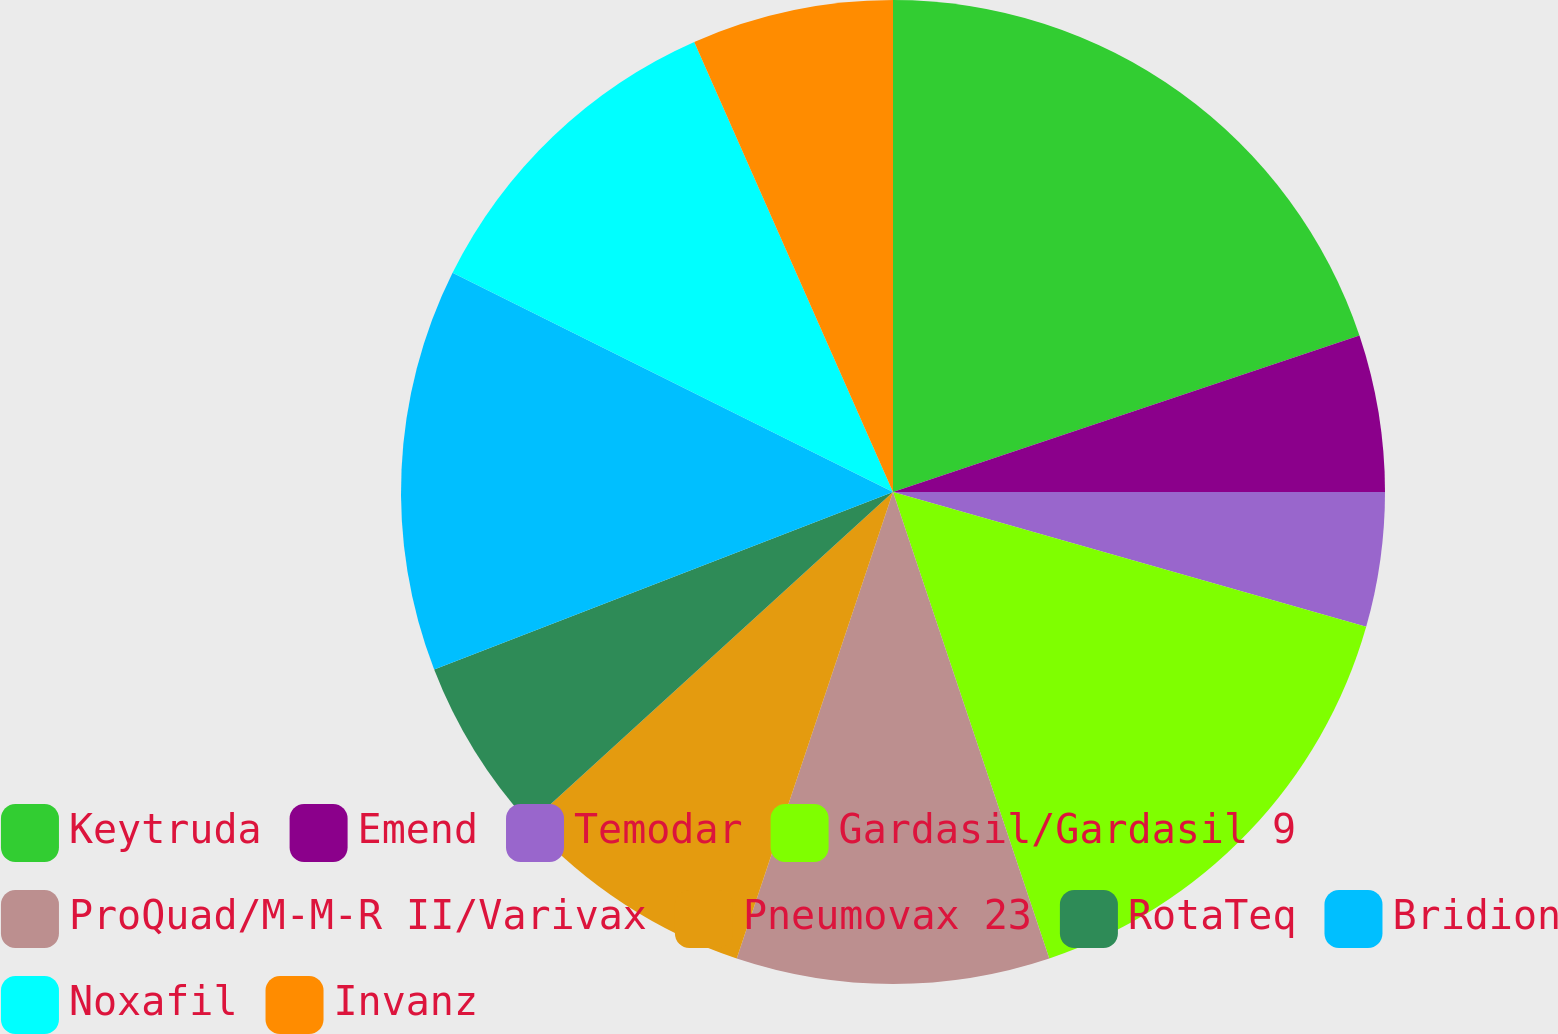Convert chart. <chart><loc_0><loc_0><loc_500><loc_500><pie_chart><fcel>Keytruda<fcel>Emend<fcel>Temodar<fcel>Gardasil/Gardasil 9<fcel>ProQuad/M-M-R II/Varivax<fcel>Pneumovax 23<fcel>RotaTeq<fcel>Bridion<fcel>Noxafil<fcel>Invanz<nl><fcel>19.85%<fcel>5.15%<fcel>4.42%<fcel>15.44%<fcel>10.29%<fcel>8.09%<fcel>5.89%<fcel>13.23%<fcel>11.03%<fcel>6.62%<nl></chart> 